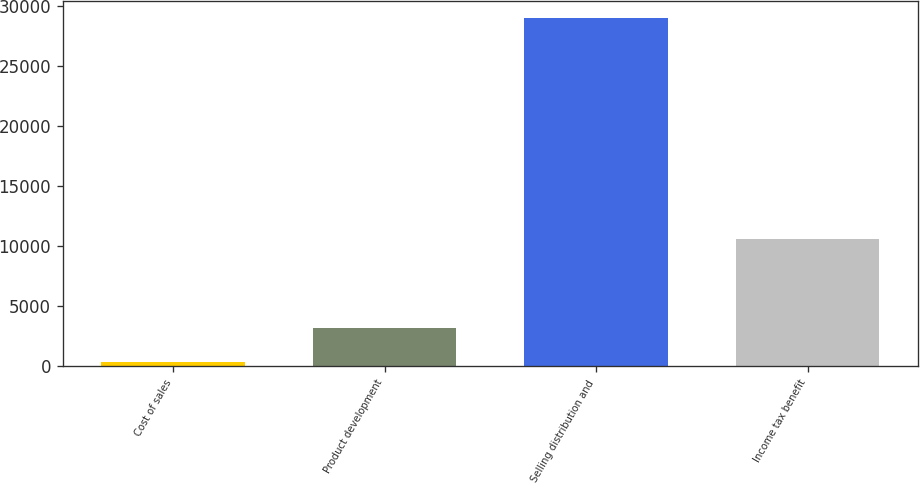<chart> <loc_0><loc_0><loc_500><loc_500><bar_chart><fcel>Cost of sales<fcel>Product development<fcel>Selling distribution and<fcel>Income tax benefit<nl><fcel>349<fcel>3216.8<fcel>29027<fcel>10658<nl></chart> 